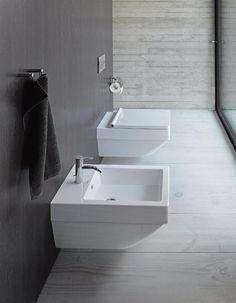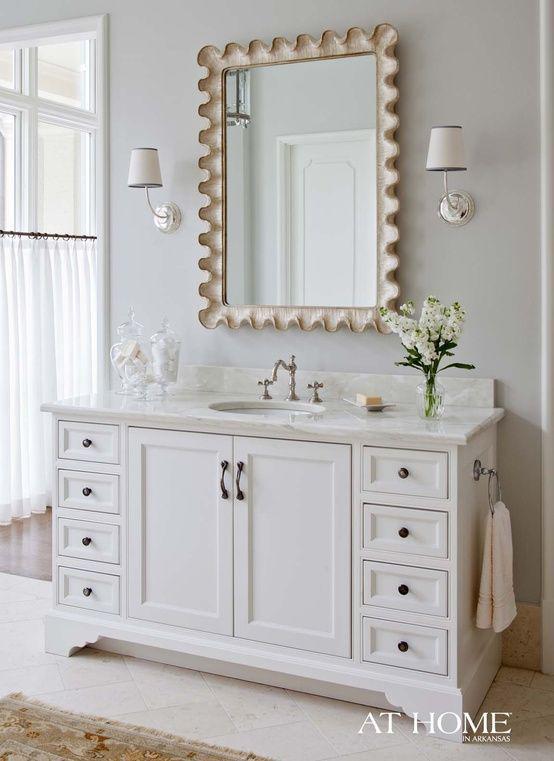The first image is the image on the left, the second image is the image on the right. Considering the images on both sides, is "In the image to the right, we have a bathtub." valid? Answer yes or no. No. 